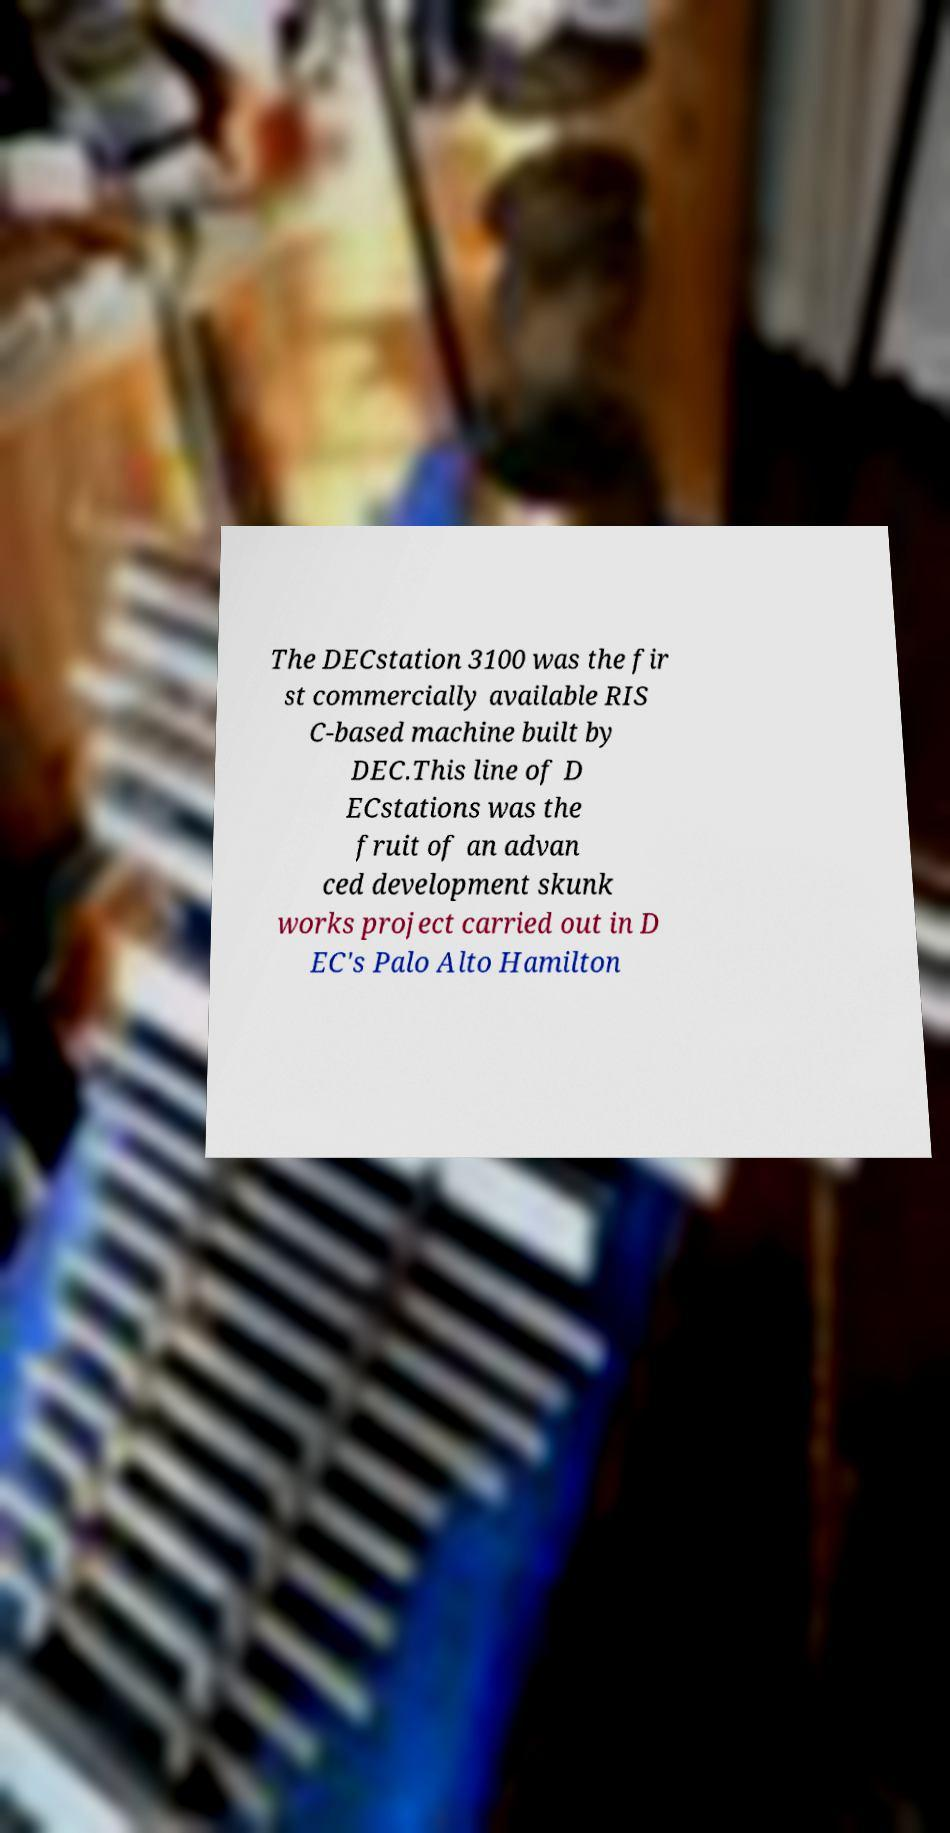Can you read and provide the text displayed in the image?This photo seems to have some interesting text. Can you extract and type it out for me? The DECstation 3100 was the fir st commercially available RIS C-based machine built by DEC.This line of D ECstations was the fruit of an advan ced development skunk works project carried out in D EC's Palo Alto Hamilton 